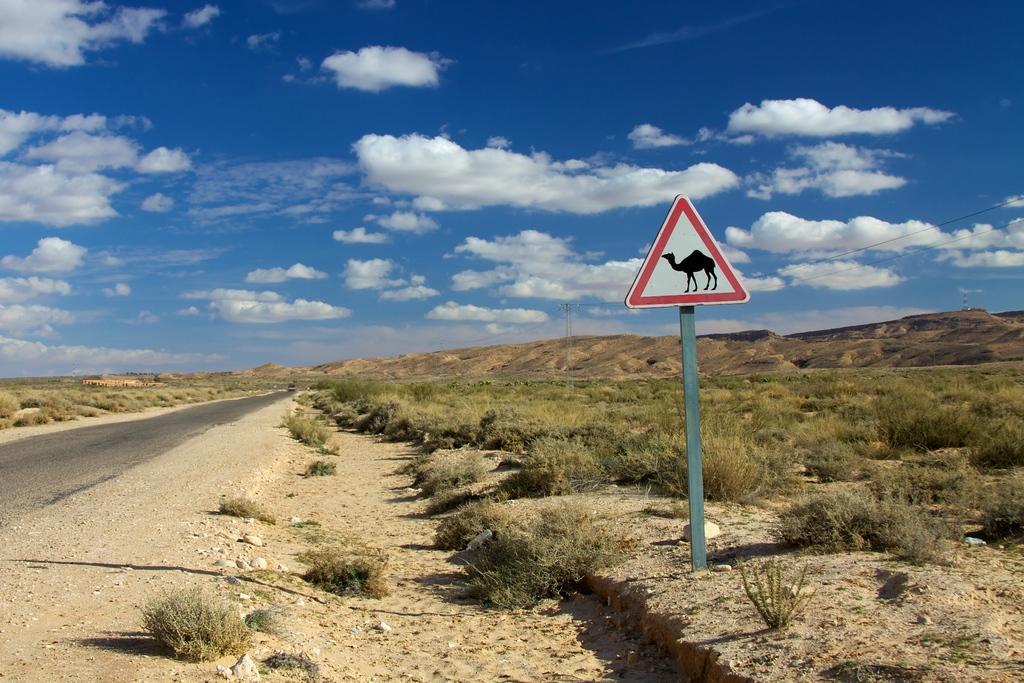Please provide a concise description of this image. This is the picture of a place where we have some trees, plants, mountains and also we can see a pole to which there is a board. 